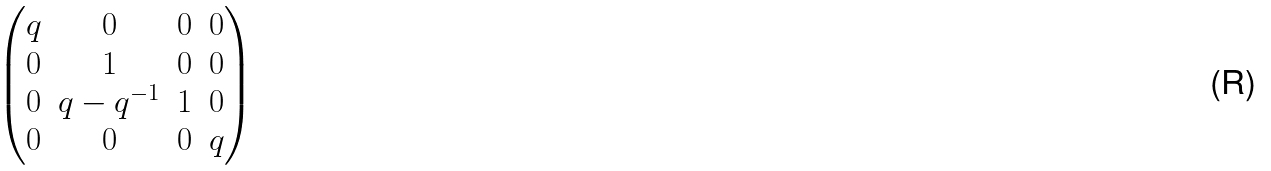Convert formula to latex. <formula><loc_0><loc_0><loc_500><loc_500>\begin{pmatrix} q & 0 & 0 & 0 \\ 0 & 1 & 0 & 0 \\ 0 & q - q ^ { - 1 } & 1 & 0 \\ 0 & 0 & 0 & q \end{pmatrix}</formula> 